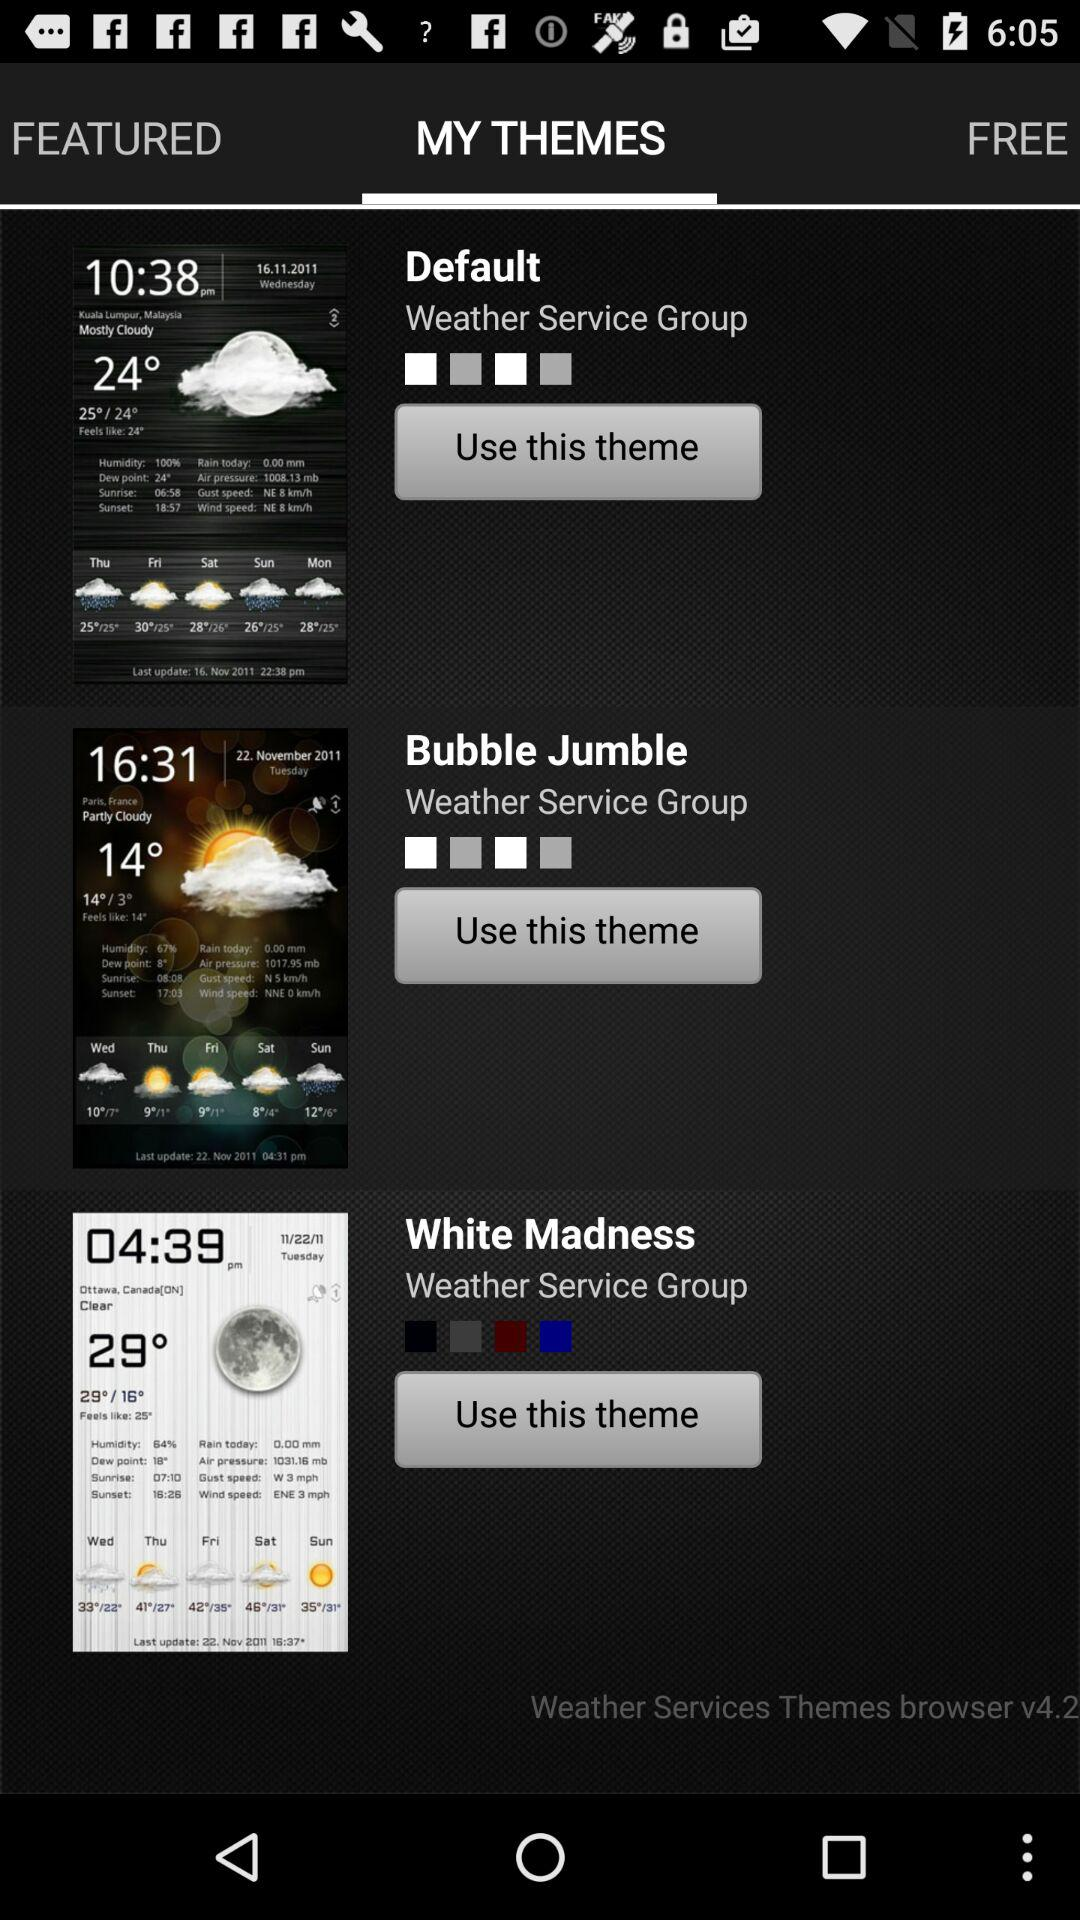Which option has been selected? The option "MY THEMES" has been selected. 